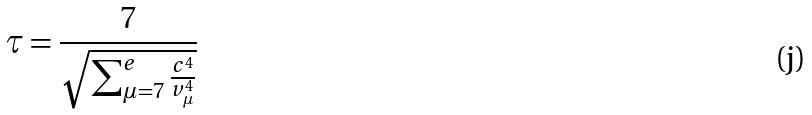Convert formula to latex. <formula><loc_0><loc_0><loc_500><loc_500>\tau = \frac { 7 } { \sqrt { \sum _ { \mu = 7 } ^ { e } \frac { c ^ { 4 } } { v _ { \mu } ^ { 4 } } } }</formula> 